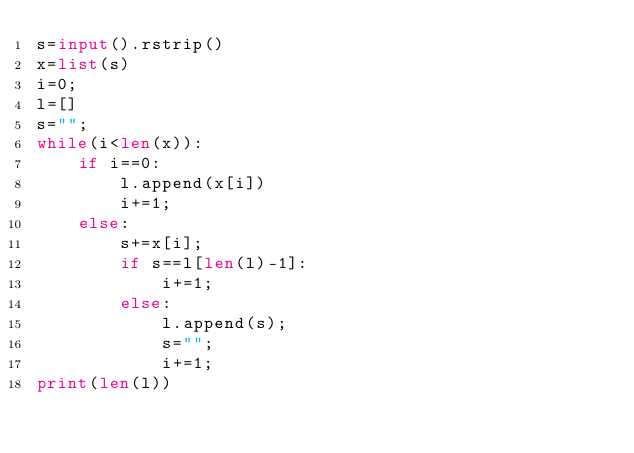<code> <loc_0><loc_0><loc_500><loc_500><_Python_>s=input().rstrip()
x=list(s)
i=0;
l=[]
s="";
while(i<len(x)):
    if i==0:
        l.append(x[i])
        i+=1;
    else:
        s+=x[i];
        if s==l[len(l)-1]:
            i+=1;
        else:
            l.append(s);
            s="";
            i+=1;
print(len(l))</code> 